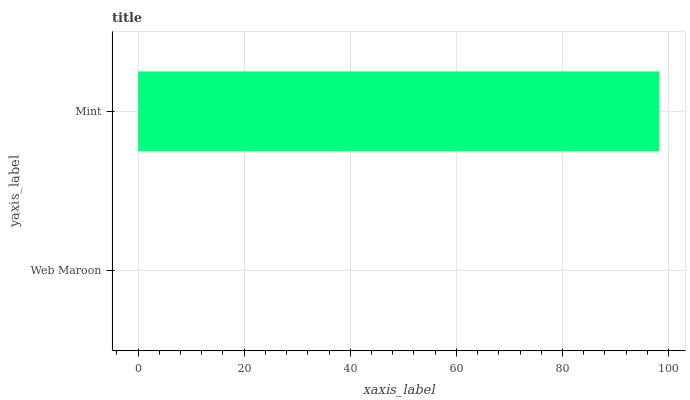Is Web Maroon the minimum?
Answer yes or no. Yes. Is Mint the maximum?
Answer yes or no. Yes. Is Mint the minimum?
Answer yes or no. No. Is Mint greater than Web Maroon?
Answer yes or no. Yes. Is Web Maroon less than Mint?
Answer yes or no. Yes. Is Web Maroon greater than Mint?
Answer yes or no. No. Is Mint less than Web Maroon?
Answer yes or no. No. Is Mint the high median?
Answer yes or no. Yes. Is Web Maroon the low median?
Answer yes or no. Yes. Is Web Maroon the high median?
Answer yes or no. No. Is Mint the low median?
Answer yes or no. No. 